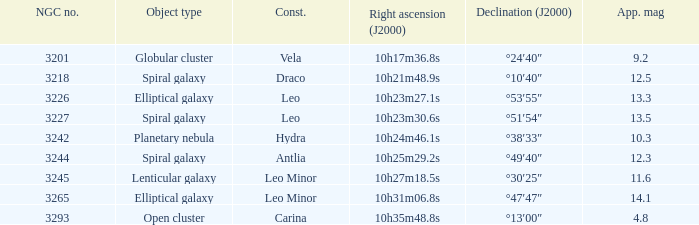What is the Apparent magnitude of a globular cluster? 9.2. 